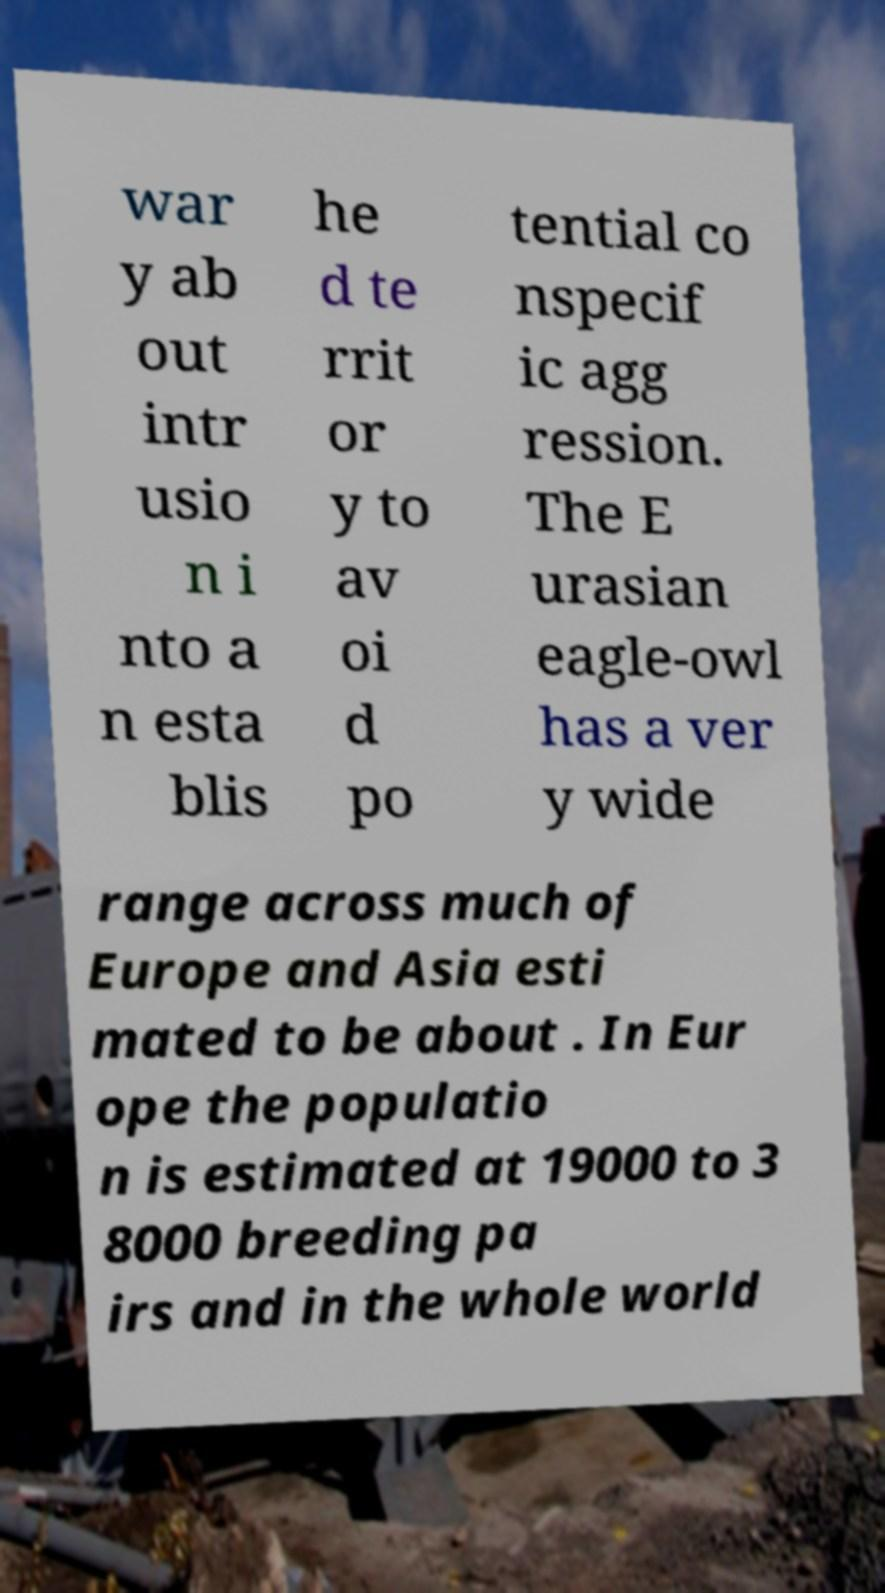I need the written content from this picture converted into text. Can you do that? war y ab out intr usio n i nto a n esta blis he d te rrit or y to av oi d po tential co nspecif ic agg ression. The E urasian eagle-owl has a ver y wide range across much of Europe and Asia esti mated to be about . In Eur ope the populatio n is estimated at 19000 to 3 8000 breeding pa irs and in the whole world 